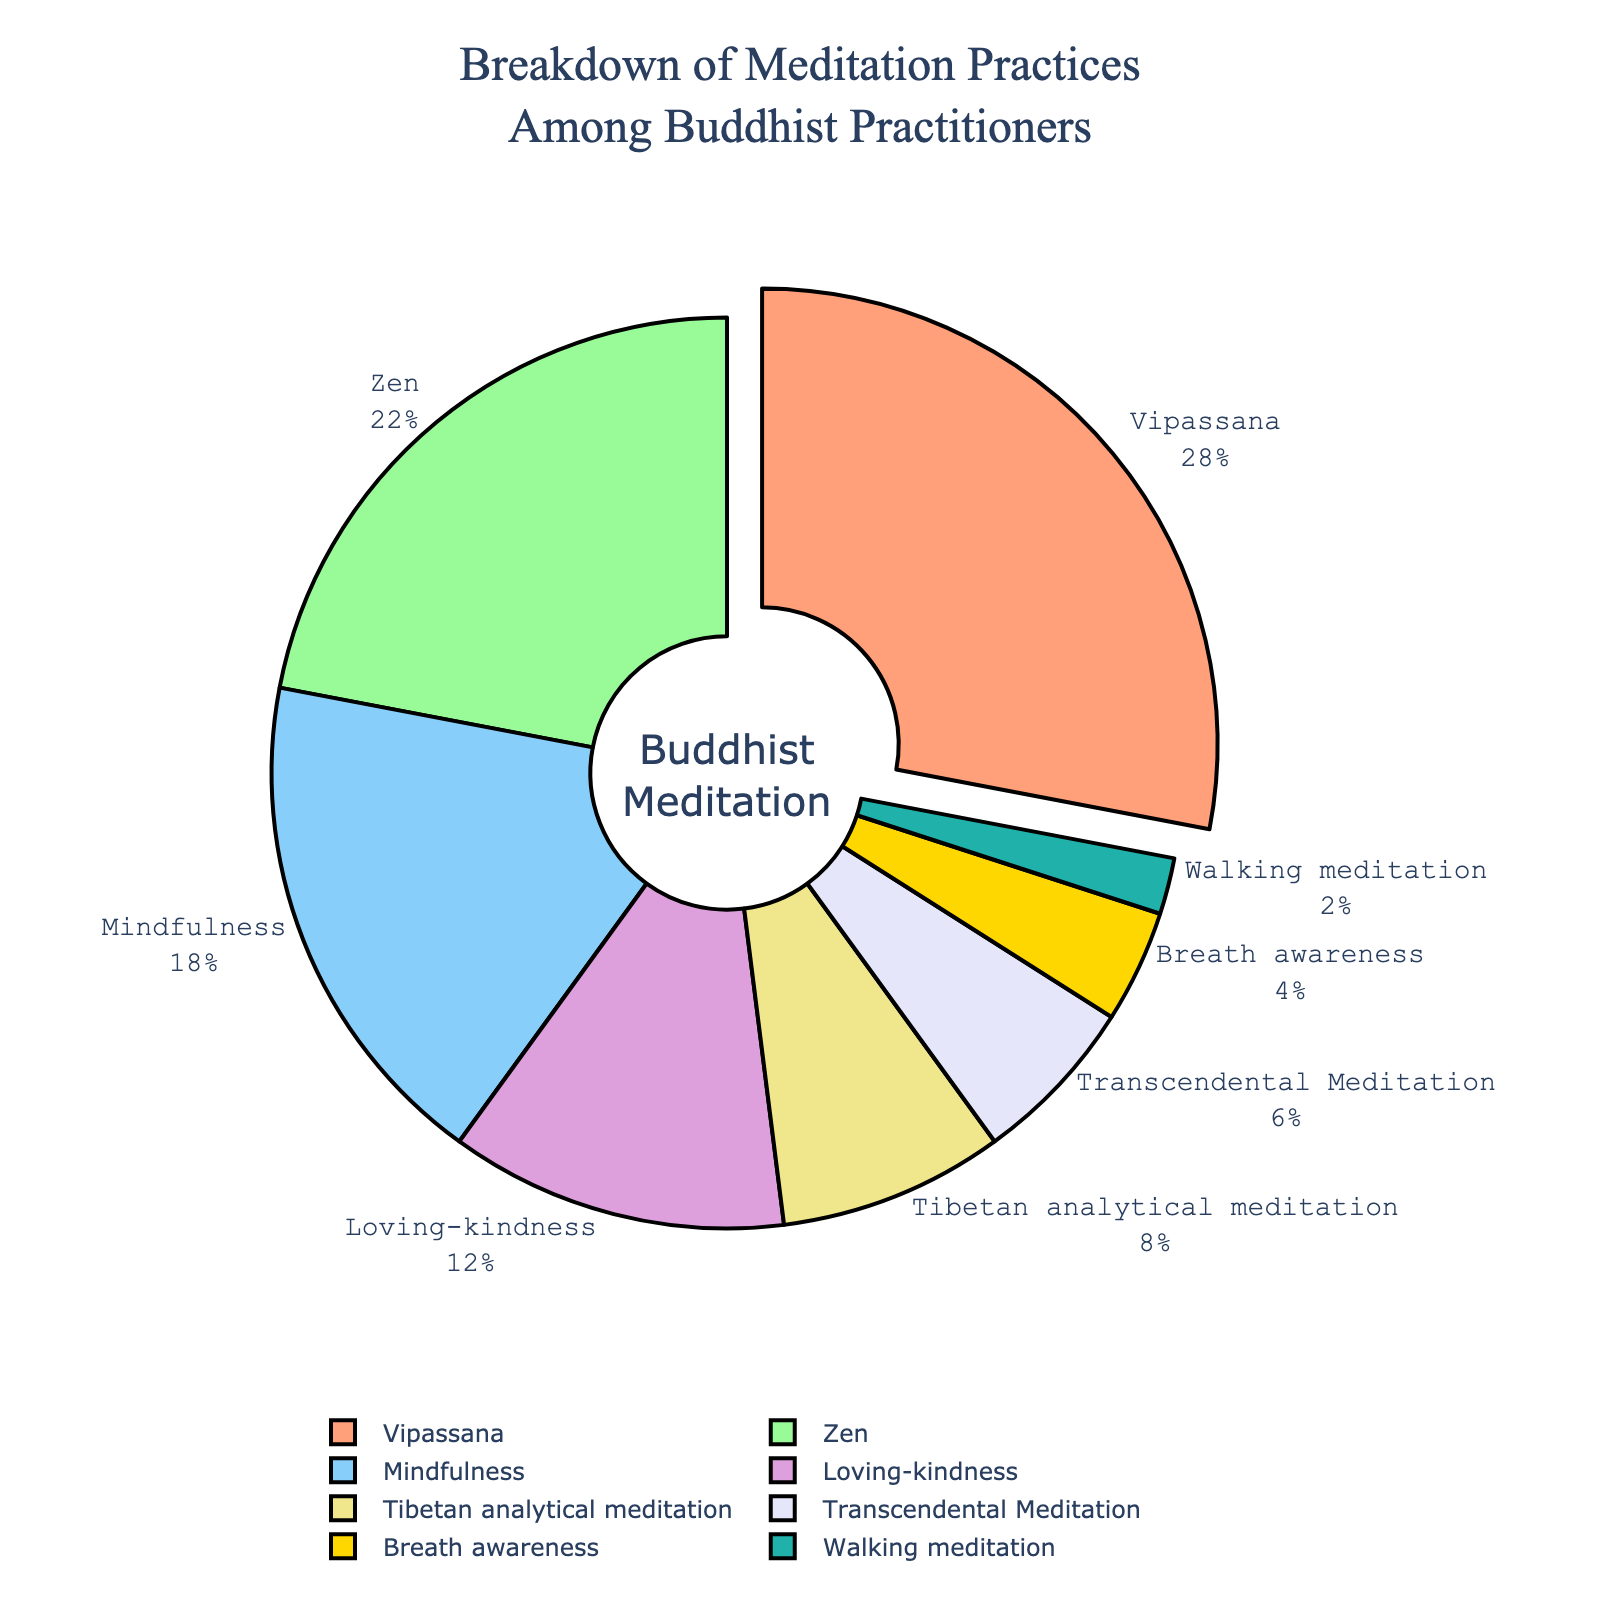Which meditation type is the most practiced among Buddhist practitioners? The "Breakdown of Meditation Practices Among Buddhist Practitioners" title suggests the pie chart captures different meditation practices. According to the chart, Vipassana has the largest slice, indicating it has the highest percentage.
Answer: Vipassana What's the combined percentage of Mindfulness and Loving-kindness meditation practices? From the chart, Mindfulness has 18% and Loving-kindness has 12%. The combined percentage is 18% + 12% = 30%.
Answer: 30% Which meditation practices combined account for less than 10%? Looking at the percentages on the chart, Breath awareness (4%) and Walking meditation (2%) are the only practices individually less than 10%, and together they sum to 6%, also less than 10%.
Answer: Breath awareness and Walking meditation How much smaller is the percentage of Transcendental Meditation compared to Vipassana? Vipassana has 28% while Transcendental Meditation has 6%. The difference is 28% - 6% = 22%.
Answer: 22% Which practices together account for exactly 50% of the breakdown? Examining the chart data, Vipassana (28%) and Zen (22%) together sum up to 28% + 22% = 50%.
Answer: Vipassana and Zen What fraction of the pie chart does Tibetan analytical meditation represent in comparison to Zen? Zen has 22% while Tibetan analytical meditation has 8%. The fraction is 8% / 22% = 0.36, which simplifies to approximately 0.36.
Answer: 0.36 What is the median percentage of all meditation practices listed in the pie chart? Listing the percentages in ascending order (2, 4, 6, 8, 12, 18, 22, 28), the middle values are 8 and 12. The median is (8 + 12) / 2 = 10.
Answer: 10% Is the percentage of people practicing Mindfulness greater than that of Loving-kindness and Breath awareness combined? Mindfulness has 18%, while Loving-kindness and Breath awareness combined have 12% + 4% = 16%. 18% is greater than 16%.
Answer: Yes Identify the slice with the smallest percentage and its corresponding meditation type. Observing the pie chart, Walking meditation has the smallest slice representing 2%.
Answer: Walking meditation Which color is used for the largest slice in the pie chart? The legend or direct observation of the pie chart indicates that the largest slice (Vipassana) is colored light red or salmon.
Answer: Light red or salmon 